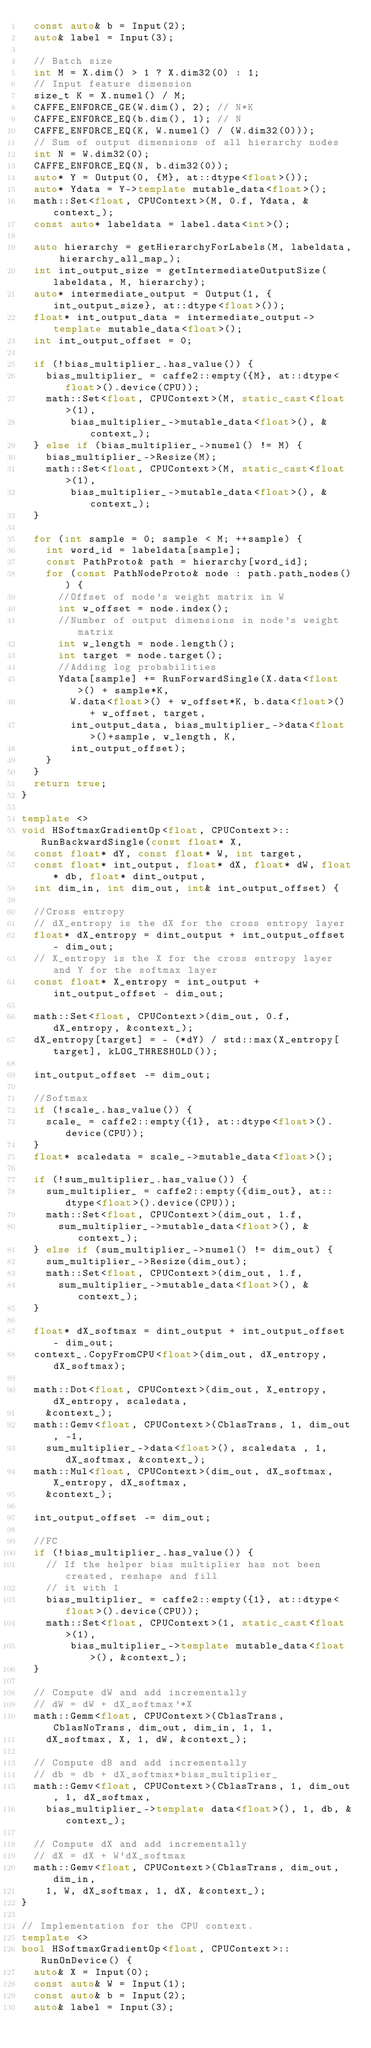Convert code to text. <code><loc_0><loc_0><loc_500><loc_500><_C++_>  const auto& b = Input(2);
  auto& label = Input(3);

  // Batch size
  int M = X.dim() > 1 ? X.dim32(0) : 1;
  // Input feature dimension
  size_t K = X.numel() / M;
  CAFFE_ENFORCE_GE(W.dim(), 2); // N*K
  CAFFE_ENFORCE_EQ(b.dim(), 1); // N
  CAFFE_ENFORCE_EQ(K, W.numel() / (W.dim32(0)));
  // Sum of output dimensions of all hierarchy nodes
  int N = W.dim32(0);
  CAFFE_ENFORCE_EQ(N, b.dim32(0));
  auto* Y = Output(0, {M}, at::dtype<float>());
  auto* Ydata = Y->template mutable_data<float>();
  math::Set<float, CPUContext>(M, 0.f, Ydata, &context_);
  const auto* labeldata = label.data<int>();

  auto hierarchy = getHierarchyForLabels(M, labeldata, hierarchy_all_map_);
  int int_output_size = getIntermediateOutputSize(labeldata, M, hierarchy);
  auto* intermediate_output = Output(1, {int_output_size}, at::dtype<float>());
  float* int_output_data = intermediate_output->template mutable_data<float>();
  int int_output_offset = 0;

  if (!bias_multiplier_.has_value()) {
    bias_multiplier_ = caffe2::empty({M}, at::dtype<float>().device(CPU));
    math::Set<float, CPUContext>(M, static_cast<float>(1),
        bias_multiplier_->mutable_data<float>(), &context_);
  } else if (bias_multiplier_->numel() != M) {
    bias_multiplier_->Resize(M);
    math::Set<float, CPUContext>(M, static_cast<float>(1),
        bias_multiplier_->mutable_data<float>(), &context_);
  }

  for (int sample = 0; sample < M; ++sample) {
    int word_id = labeldata[sample];
    const PathProto& path = hierarchy[word_id];
    for (const PathNodeProto& node : path.path_nodes()) {
      //Offset of node's weight matrix in W
      int w_offset = node.index();
      //Number of output dimensions in node's weight matrix
      int w_length = node.length();
      int target = node.target();
      //Adding log probabilities
      Ydata[sample] += RunForwardSingle(X.data<float>() + sample*K,
        W.data<float>() + w_offset*K, b.data<float>() + w_offset, target,
        int_output_data, bias_multiplier_->data<float>()+sample, w_length, K,
        int_output_offset);
    }
  }
  return true;
}

template <>
void HSoftmaxGradientOp<float, CPUContext>::RunBackwardSingle(const float* X,
  const float* dY, const float* W, int target,
  const float* int_output, float* dX, float* dW, float* db, float* dint_output,
  int dim_in, int dim_out, int& int_output_offset) {

  //Cross entropy
  // dX_entropy is the dX for the cross entropy layer
  float* dX_entropy = dint_output + int_output_offset - dim_out;
  // X_entropy is the X for the cross entropy layer and Y for the softmax layer
  const float* X_entropy = int_output + int_output_offset - dim_out;

  math::Set<float, CPUContext>(dim_out, 0.f, dX_entropy, &context_);
  dX_entropy[target] = - (*dY) / std::max(X_entropy[target], kLOG_THRESHOLD());

  int_output_offset -= dim_out;

  //Softmax
  if (!scale_.has_value()) {
    scale_ = caffe2::empty({1}, at::dtype<float>().device(CPU));
  }
  float* scaledata = scale_->mutable_data<float>();

  if (!sum_multiplier_.has_value()) {
    sum_multiplier_ = caffe2::empty({dim_out}, at::dtype<float>().device(CPU));
    math::Set<float, CPUContext>(dim_out, 1.f,
      sum_multiplier_->mutable_data<float>(), &context_);
  } else if (sum_multiplier_->numel() != dim_out) {
    sum_multiplier_->Resize(dim_out);
    math::Set<float, CPUContext>(dim_out, 1.f,
      sum_multiplier_->mutable_data<float>(), &context_);
  }

  float* dX_softmax = dint_output + int_output_offset - dim_out;
  context_.CopyFromCPU<float>(dim_out, dX_entropy, dX_softmax);

  math::Dot<float, CPUContext>(dim_out, X_entropy, dX_entropy, scaledata,
    &context_);
  math::Gemv<float, CPUContext>(CblasTrans, 1, dim_out, -1,
    sum_multiplier_->data<float>(), scaledata , 1, dX_softmax, &context_);
  math::Mul<float, CPUContext>(dim_out, dX_softmax, X_entropy, dX_softmax,
    &context_);

  int_output_offset -= dim_out;

  //FC
  if (!bias_multiplier_.has_value()) {
    // If the helper bias multiplier has not been created, reshape and fill
    // it with 1
    bias_multiplier_ = caffe2::empty({1}, at::dtype<float>().device(CPU));
    math::Set<float, CPUContext>(1, static_cast<float>(1),
        bias_multiplier_->template mutable_data<float>(), &context_);
  }

  // Compute dW and add incrementally
  // dW = dW + dX_softmax'*X
  math::Gemm<float, CPUContext>(CblasTrans, CblasNoTrans, dim_out, dim_in, 1, 1,
    dX_softmax, X, 1, dW, &context_);

  // Compute dB and add incrementally
  // db = db + dX_softmax*bias_multiplier_
  math::Gemv<float, CPUContext>(CblasTrans, 1, dim_out, 1, dX_softmax,
    bias_multiplier_->template data<float>(), 1, db, &context_);

  // Compute dX and add incrementally
  // dX = dX + W'dX_softmax
  math::Gemv<float, CPUContext>(CblasTrans, dim_out, dim_in,
    1, W, dX_softmax, 1, dX, &context_);
}

// Implementation for the CPU context.
template <>
bool HSoftmaxGradientOp<float, CPUContext>::RunOnDevice() {
  auto& X = Input(0);
  const auto& W = Input(1);
  const auto& b = Input(2);
  auto& label = Input(3);</code> 